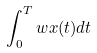Convert formula to latex. <formula><loc_0><loc_0><loc_500><loc_500>\int _ { 0 } ^ { T } w x ( t ) d t</formula> 